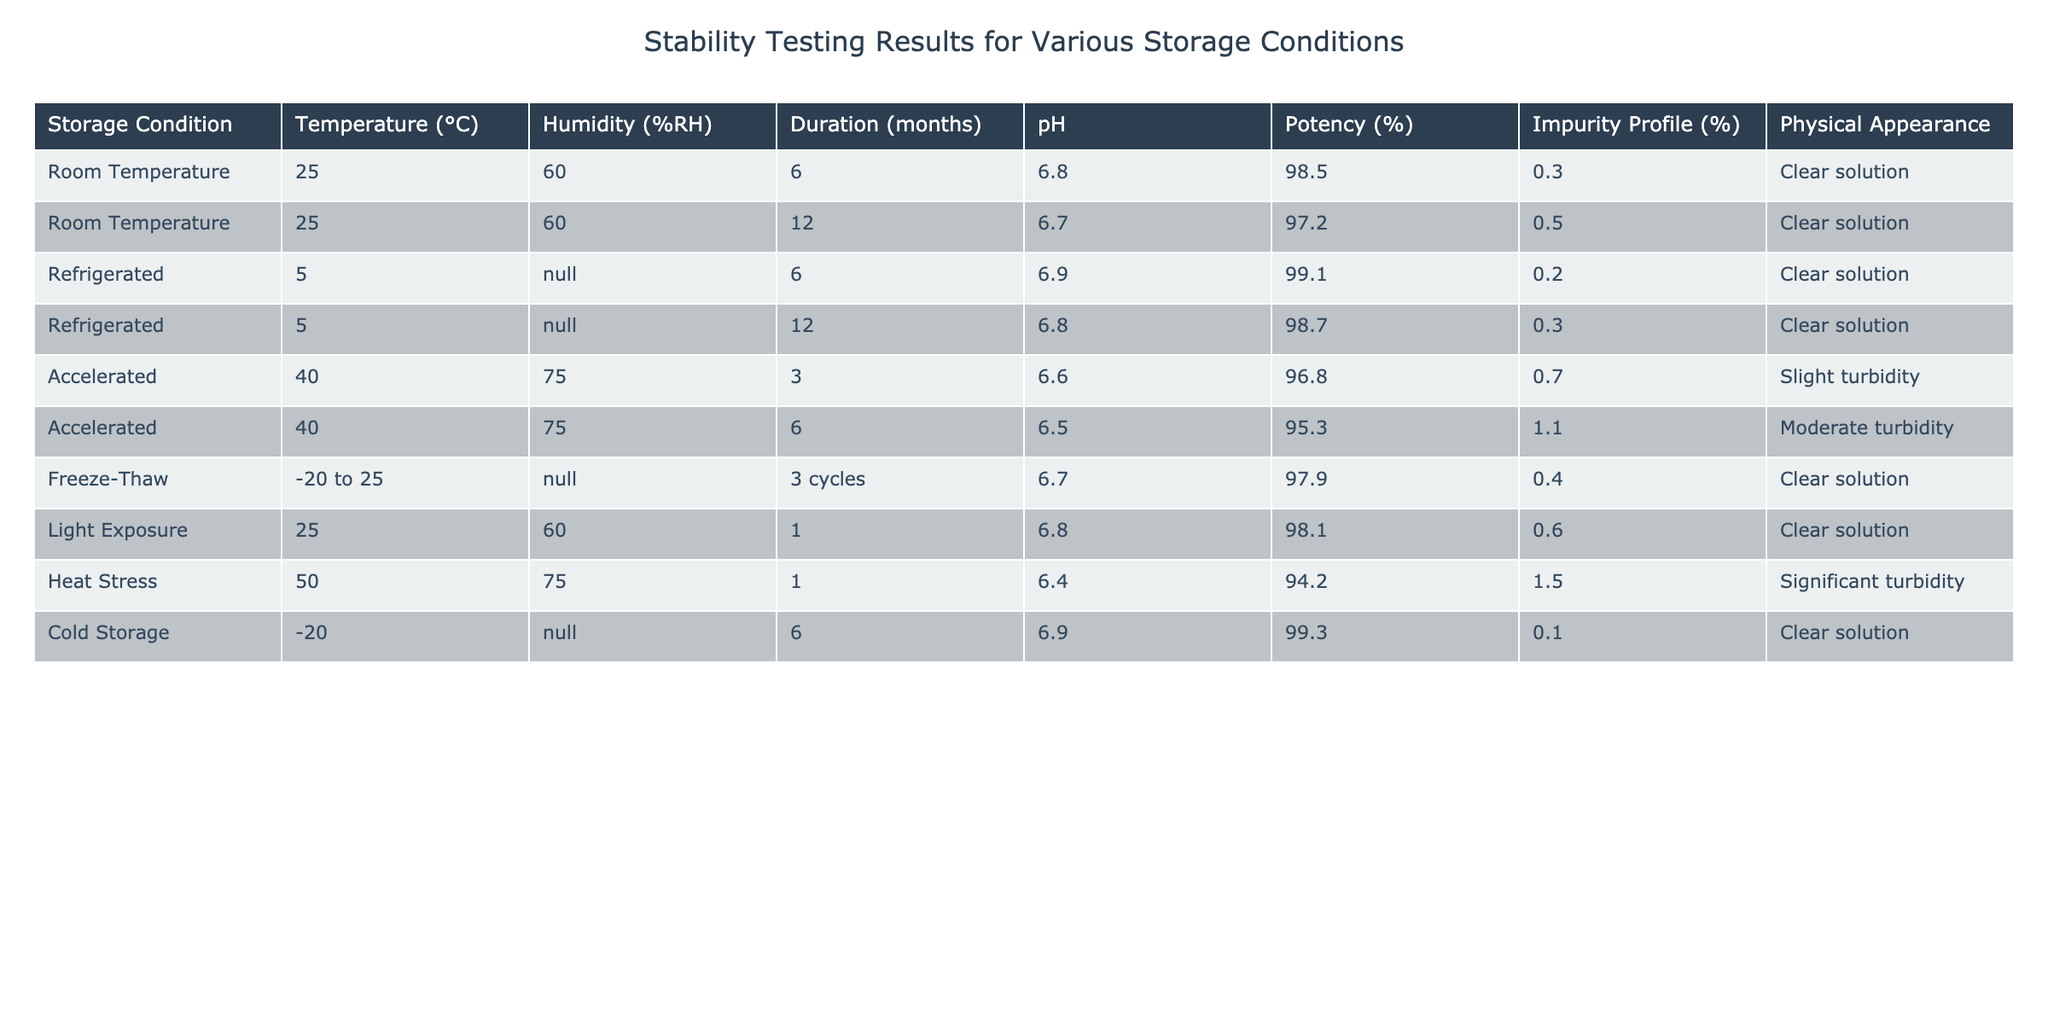What is the potency percentage of the potential cure stored at room temperature for 12 months? The table shows a record of the potency percentage for the cure stored at room temperature for 12 months, which is explicitly listed as 97.2%.
Answer: 97.2% What is the pH level of the potential cure when stored under accelerated conditions for 6 months? Looking at the accelerated conditions row for 6 months, the pH level is given as 6.5.
Answer: 6.5 Which storage condition resulted in the most significant turbidity? The Heat Stress row indicates "Significant turbidity," which is the highest level of turbidity mentioned in the table.
Answer: Heat Stress What is the average potency percentage for the potential cure under refrigerated conditions over the tested durations? The potency values for refrigerated conditions are 99.1% (6 months) and 98.7% (12 months). Adding these values gives 99.1 + 98.7 = 197.8. Dividing by 2 (the number of records) gives an average potency of 197.8/2 = 98.9%.
Answer: 98.9% Is the impurity profile higher at accelerated conditions for 3 months or at heat stress for 1 month? The impurity profile for accelerated conditions (3 months) is 0.7% and for heat stress (1 month) is 1.5%. Since 1.5% is greater than 0.7%, the impurity profile is indeed higher under heat stress conditions.
Answer: Yes What is the change in pH from the refrigerated storage condition after 6 months to the same condition after 12 months? The refrigerated storage condition shows a pH of 6.9% after 6 months and 6.8% after 12 months. The change can be calculated as 6.9 - 6.8 = 0.1, indicating a decrease in pH.
Answer: 0.1 decrease If the potential cure stored under cold storage has a potency of 99.3%, is this higher or lower than the potency at room temperature after 6 months? The potency at room temperature after 6 months is 98.5%. Since 99.3% is greater than 98.5%, the potency in cold storage is indeed higher.
Answer: Higher Under which storage condition and duration does the potential cure have the least impurity profile? From the table, the lowest impurity profile is 0.1%, recorded under "Cold Storage" for 6 months.
Answer: Cold Storage for 6 months What percentage of potency loss occurred in the potential cure stored under accelerated conditions for 6 months compared to the initial potency? The initial potency (assumed as the highest value of 99.1% in refrigerated conditions) minus the potency under accelerated conditions for 6 months (95.3%) gives 99.1 - 95.3 = 3.8% potency loss.
Answer: 3.8% potency loss What physical appearance was noted for the potential cure after being exposed to heat stress for one month? The table specifies that the physical appearance after heat stress for one month is "Significant turbidity," which indicates a reduced quality.
Answer: Significant turbidity 